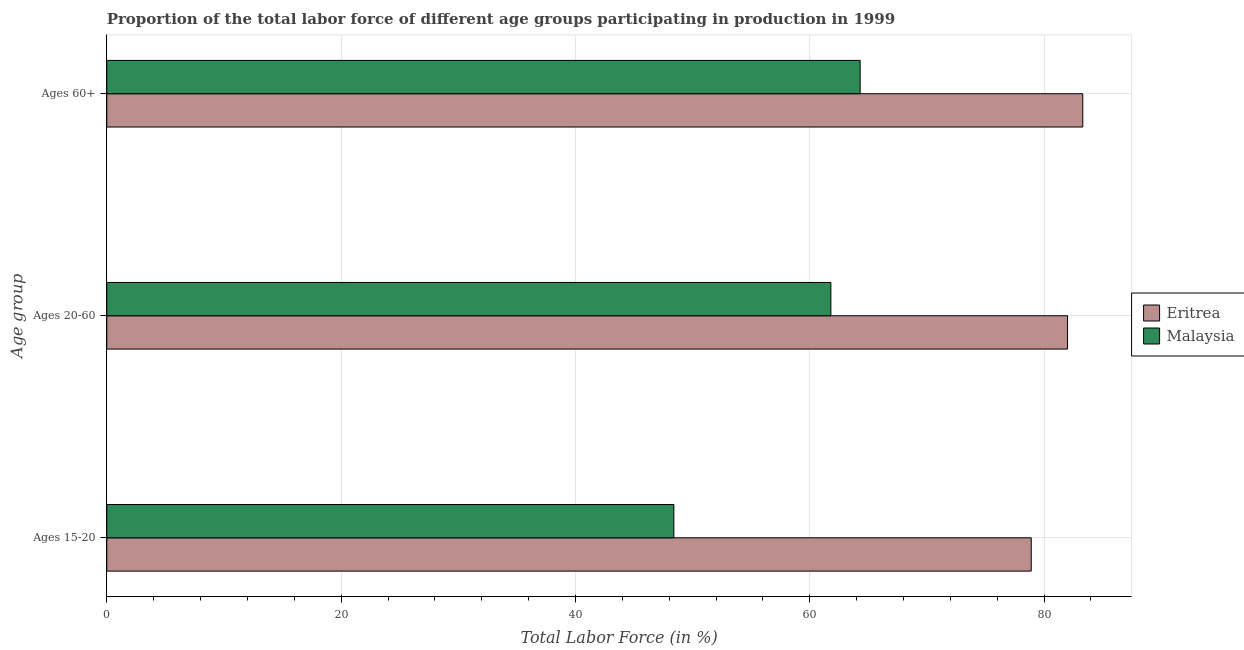How many different coloured bars are there?
Offer a very short reply. 2. How many groups of bars are there?
Provide a succinct answer. 3. How many bars are there on the 1st tick from the top?
Offer a terse response. 2. How many bars are there on the 1st tick from the bottom?
Give a very brief answer. 2. What is the label of the 1st group of bars from the top?
Provide a short and direct response. Ages 60+. What is the percentage of labor force within the age group 20-60 in Malaysia?
Your response must be concise. 61.8. Across all countries, what is the maximum percentage of labor force within the age group 15-20?
Provide a succinct answer. 78.9. Across all countries, what is the minimum percentage of labor force within the age group 20-60?
Keep it short and to the point. 61.8. In which country was the percentage of labor force within the age group 15-20 maximum?
Your response must be concise. Eritrea. In which country was the percentage of labor force within the age group 15-20 minimum?
Offer a very short reply. Malaysia. What is the total percentage of labor force above age 60 in the graph?
Provide a short and direct response. 147.6. What is the difference between the percentage of labor force within the age group 20-60 in Eritrea and that in Malaysia?
Your answer should be very brief. 20.2. What is the difference between the percentage of labor force above age 60 in Eritrea and the percentage of labor force within the age group 20-60 in Malaysia?
Your response must be concise. 21.5. What is the average percentage of labor force above age 60 per country?
Provide a short and direct response. 73.8. What is the difference between the percentage of labor force within the age group 20-60 and percentage of labor force within the age group 15-20 in Malaysia?
Provide a succinct answer. 13.4. What is the ratio of the percentage of labor force within the age group 20-60 in Eritrea to that in Malaysia?
Your answer should be compact. 1.33. Is the percentage of labor force above age 60 in Eritrea less than that in Malaysia?
Your answer should be very brief. No. What is the difference between the highest and the second highest percentage of labor force within the age group 20-60?
Ensure brevity in your answer.  20.2. What does the 1st bar from the top in Ages 20-60 represents?
Provide a succinct answer. Malaysia. What does the 2nd bar from the bottom in Ages 60+ represents?
Your response must be concise. Malaysia. Is it the case that in every country, the sum of the percentage of labor force within the age group 15-20 and percentage of labor force within the age group 20-60 is greater than the percentage of labor force above age 60?
Offer a terse response. Yes. What is the difference between two consecutive major ticks on the X-axis?
Your answer should be compact. 20. Does the graph contain any zero values?
Keep it short and to the point. No. Does the graph contain grids?
Ensure brevity in your answer.  Yes. How are the legend labels stacked?
Provide a succinct answer. Vertical. What is the title of the graph?
Provide a succinct answer. Proportion of the total labor force of different age groups participating in production in 1999. What is the label or title of the X-axis?
Provide a succinct answer. Total Labor Force (in %). What is the label or title of the Y-axis?
Ensure brevity in your answer.  Age group. What is the Total Labor Force (in %) in Eritrea in Ages 15-20?
Give a very brief answer. 78.9. What is the Total Labor Force (in %) in Malaysia in Ages 15-20?
Offer a terse response. 48.4. What is the Total Labor Force (in %) of Malaysia in Ages 20-60?
Give a very brief answer. 61.8. What is the Total Labor Force (in %) of Eritrea in Ages 60+?
Offer a very short reply. 83.3. What is the Total Labor Force (in %) in Malaysia in Ages 60+?
Keep it short and to the point. 64.3. Across all Age group, what is the maximum Total Labor Force (in %) of Eritrea?
Provide a succinct answer. 83.3. Across all Age group, what is the maximum Total Labor Force (in %) of Malaysia?
Offer a terse response. 64.3. Across all Age group, what is the minimum Total Labor Force (in %) in Eritrea?
Offer a very short reply. 78.9. Across all Age group, what is the minimum Total Labor Force (in %) in Malaysia?
Provide a short and direct response. 48.4. What is the total Total Labor Force (in %) of Eritrea in the graph?
Your answer should be very brief. 244.2. What is the total Total Labor Force (in %) in Malaysia in the graph?
Ensure brevity in your answer.  174.5. What is the difference between the Total Labor Force (in %) of Malaysia in Ages 15-20 and that in Ages 20-60?
Provide a succinct answer. -13.4. What is the difference between the Total Labor Force (in %) in Malaysia in Ages 15-20 and that in Ages 60+?
Ensure brevity in your answer.  -15.9. What is the difference between the Total Labor Force (in %) of Eritrea in Ages 20-60 and the Total Labor Force (in %) of Malaysia in Ages 60+?
Ensure brevity in your answer.  17.7. What is the average Total Labor Force (in %) in Eritrea per Age group?
Give a very brief answer. 81.4. What is the average Total Labor Force (in %) of Malaysia per Age group?
Offer a very short reply. 58.17. What is the difference between the Total Labor Force (in %) in Eritrea and Total Labor Force (in %) in Malaysia in Ages 15-20?
Offer a very short reply. 30.5. What is the difference between the Total Labor Force (in %) in Eritrea and Total Labor Force (in %) in Malaysia in Ages 20-60?
Your answer should be very brief. 20.2. What is the difference between the Total Labor Force (in %) of Eritrea and Total Labor Force (in %) of Malaysia in Ages 60+?
Give a very brief answer. 19. What is the ratio of the Total Labor Force (in %) of Eritrea in Ages 15-20 to that in Ages 20-60?
Your answer should be compact. 0.96. What is the ratio of the Total Labor Force (in %) in Malaysia in Ages 15-20 to that in Ages 20-60?
Make the answer very short. 0.78. What is the ratio of the Total Labor Force (in %) in Eritrea in Ages 15-20 to that in Ages 60+?
Ensure brevity in your answer.  0.95. What is the ratio of the Total Labor Force (in %) in Malaysia in Ages 15-20 to that in Ages 60+?
Offer a terse response. 0.75. What is the ratio of the Total Labor Force (in %) of Eritrea in Ages 20-60 to that in Ages 60+?
Your response must be concise. 0.98. What is the ratio of the Total Labor Force (in %) of Malaysia in Ages 20-60 to that in Ages 60+?
Give a very brief answer. 0.96. What is the difference between the highest and the second highest Total Labor Force (in %) in Eritrea?
Offer a terse response. 1.3. What is the difference between the highest and the lowest Total Labor Force (in %) in Eritrea?
Your answer should be very brief. 4.4. 